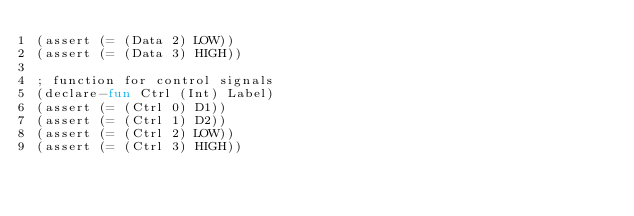Convert code to text. <code><loc_0><loc_0><loc_500><loc_500><_SML_>(assert (= (Data 2) LOW))
(assert (= (Data 3) HIGH))

; function for control signals
(declare-fun Ctrl (Int) Label)
(assert (= (Ctrl 0) D1))
(assert (= (Ctrl 1) D2))
(assert (= (Ctrl 2) LOW))
(assert (= (Ctrl 3) HIGH))
</code> 